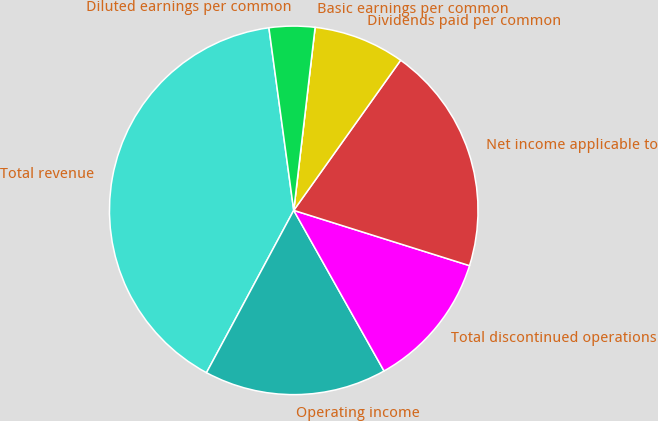Convert chart. <chart><loc_0><loc_0><loc_500><loc_500><pie_chart><fcel>Total revenue<fcel>Operating income<fcel>Total discontinued operations<fcel>Net income applicable to<fcel>Dividends paid per common<fcel>Basic earnings per common<fcel>Diluted earnings per common<nl><fcel>40.0%<fcel>16.0%<fcel>12.0%<fcel>20.0%<fcel>8.0%<fcel>0.0%<fcel>4.0%<nl></chart> 